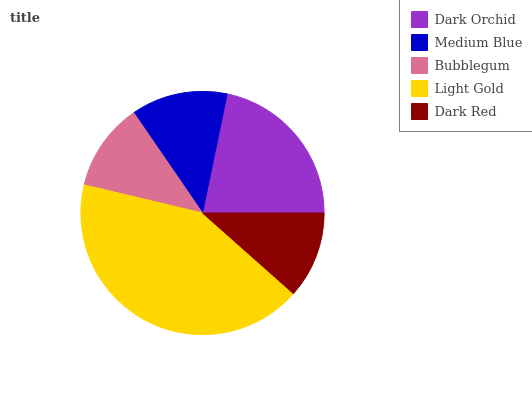Is Dark Red the minimum?
Answer yes or no. Yes. Is Light Gold the maximum?
Answer yes or no. Yes. Is Medium Blue the minimum?
Answer yes or no. No. Is Medium Blue the maximum?
Answer yes or no. No. Is Dark Orchid greater than Medium Blue?
Answer yes or no. Yes. Is Medium Blue less than Dark Orchid?
Answer yes or no. Yes. Is Medium Blue greater than Dark Orchid?
Answer yes or no. No. Is Dark Orchid less than Medium Blue?
Answer yes or no. No. Is Medium Blue the high median?
Answer yes or no. Yes. Is Medium Blue the low median?
Answer yes or no. Yes. Is Light Gold the high median?
Answer yes or no. No. Is Dark Red the low median?
Answer yes or no. No. 